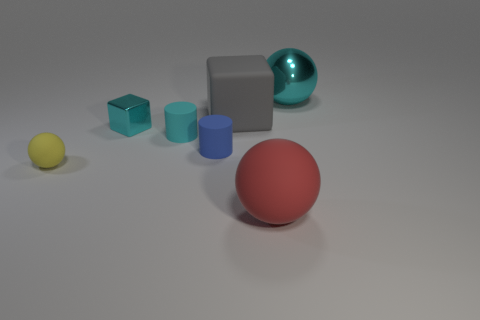Are any blue shiny blocks visible?
Keep it short and to the point. No. Does the red sphere have the same size as the sphere behind the big block?
Give a very brief answer. Yes. There is a large thing that is in front of the tiny yellow ball; is there a cyan thing left of it?
Give a very brief answer. Yes. What material is the ball that is on the right side of the small blue matte thing and on the left side of the shiny ball?
Keep it short and to the point. Rubber. There is a big sphere that is left of the big object that is on the right side of the big ball in front of the gray block; what is its color?
Give a very brief answer. Red. What is the color of the sphere that is the same size as the metal block?
Your response must be concise. Yellow. There is a small ball; is it the same color as the big sphere in front of the shiny block?
Your response must be concise. No. What material is the object right of the rubber ball that is to the right of the yellow rubber object?
Make the answer very short. Metal. How many metal things are on the left side of the big red rubber ball and on the right side of the red rubber sphere?
Your answer should be very brief. 0. How many other objects are the same size as the red object?
Your response must be concise. 2. 